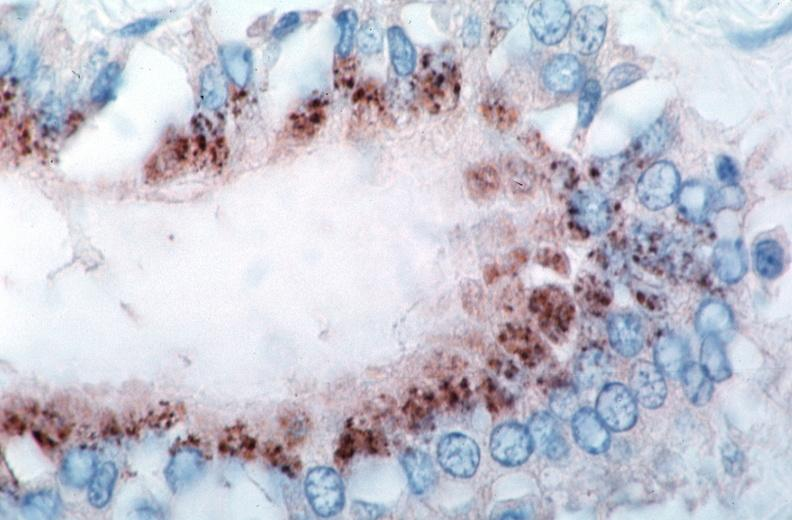where is this from?
Answer the question using a single word or phrase. Vasculature 